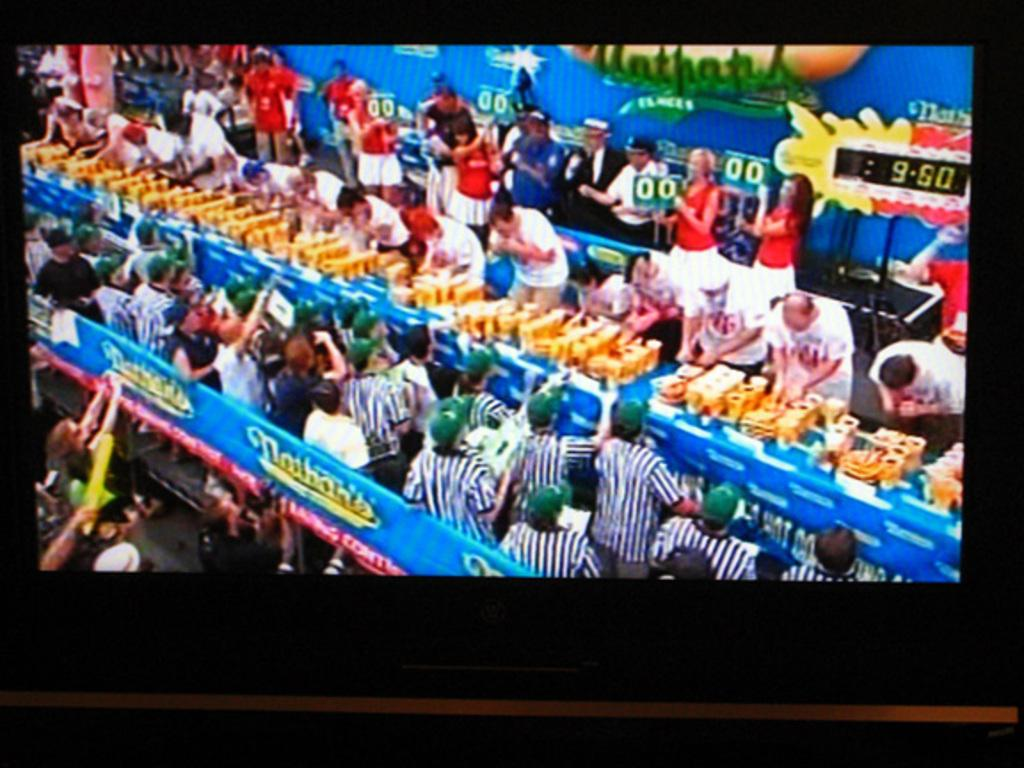<image>
Provide a brief description of the given image. A screenshot of the Nathan's annual hot dog eating contest. 